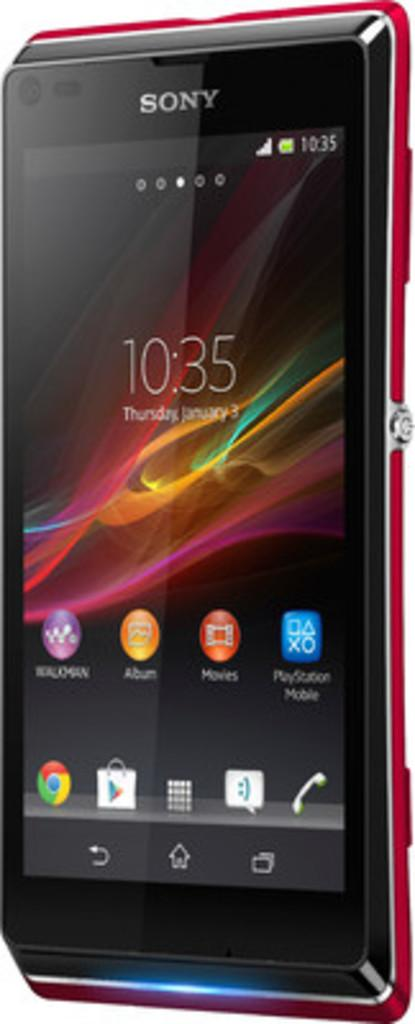<image>
Summarize the visual content of the image. a black and red sony phone with the time reading 10:35 on the screen 